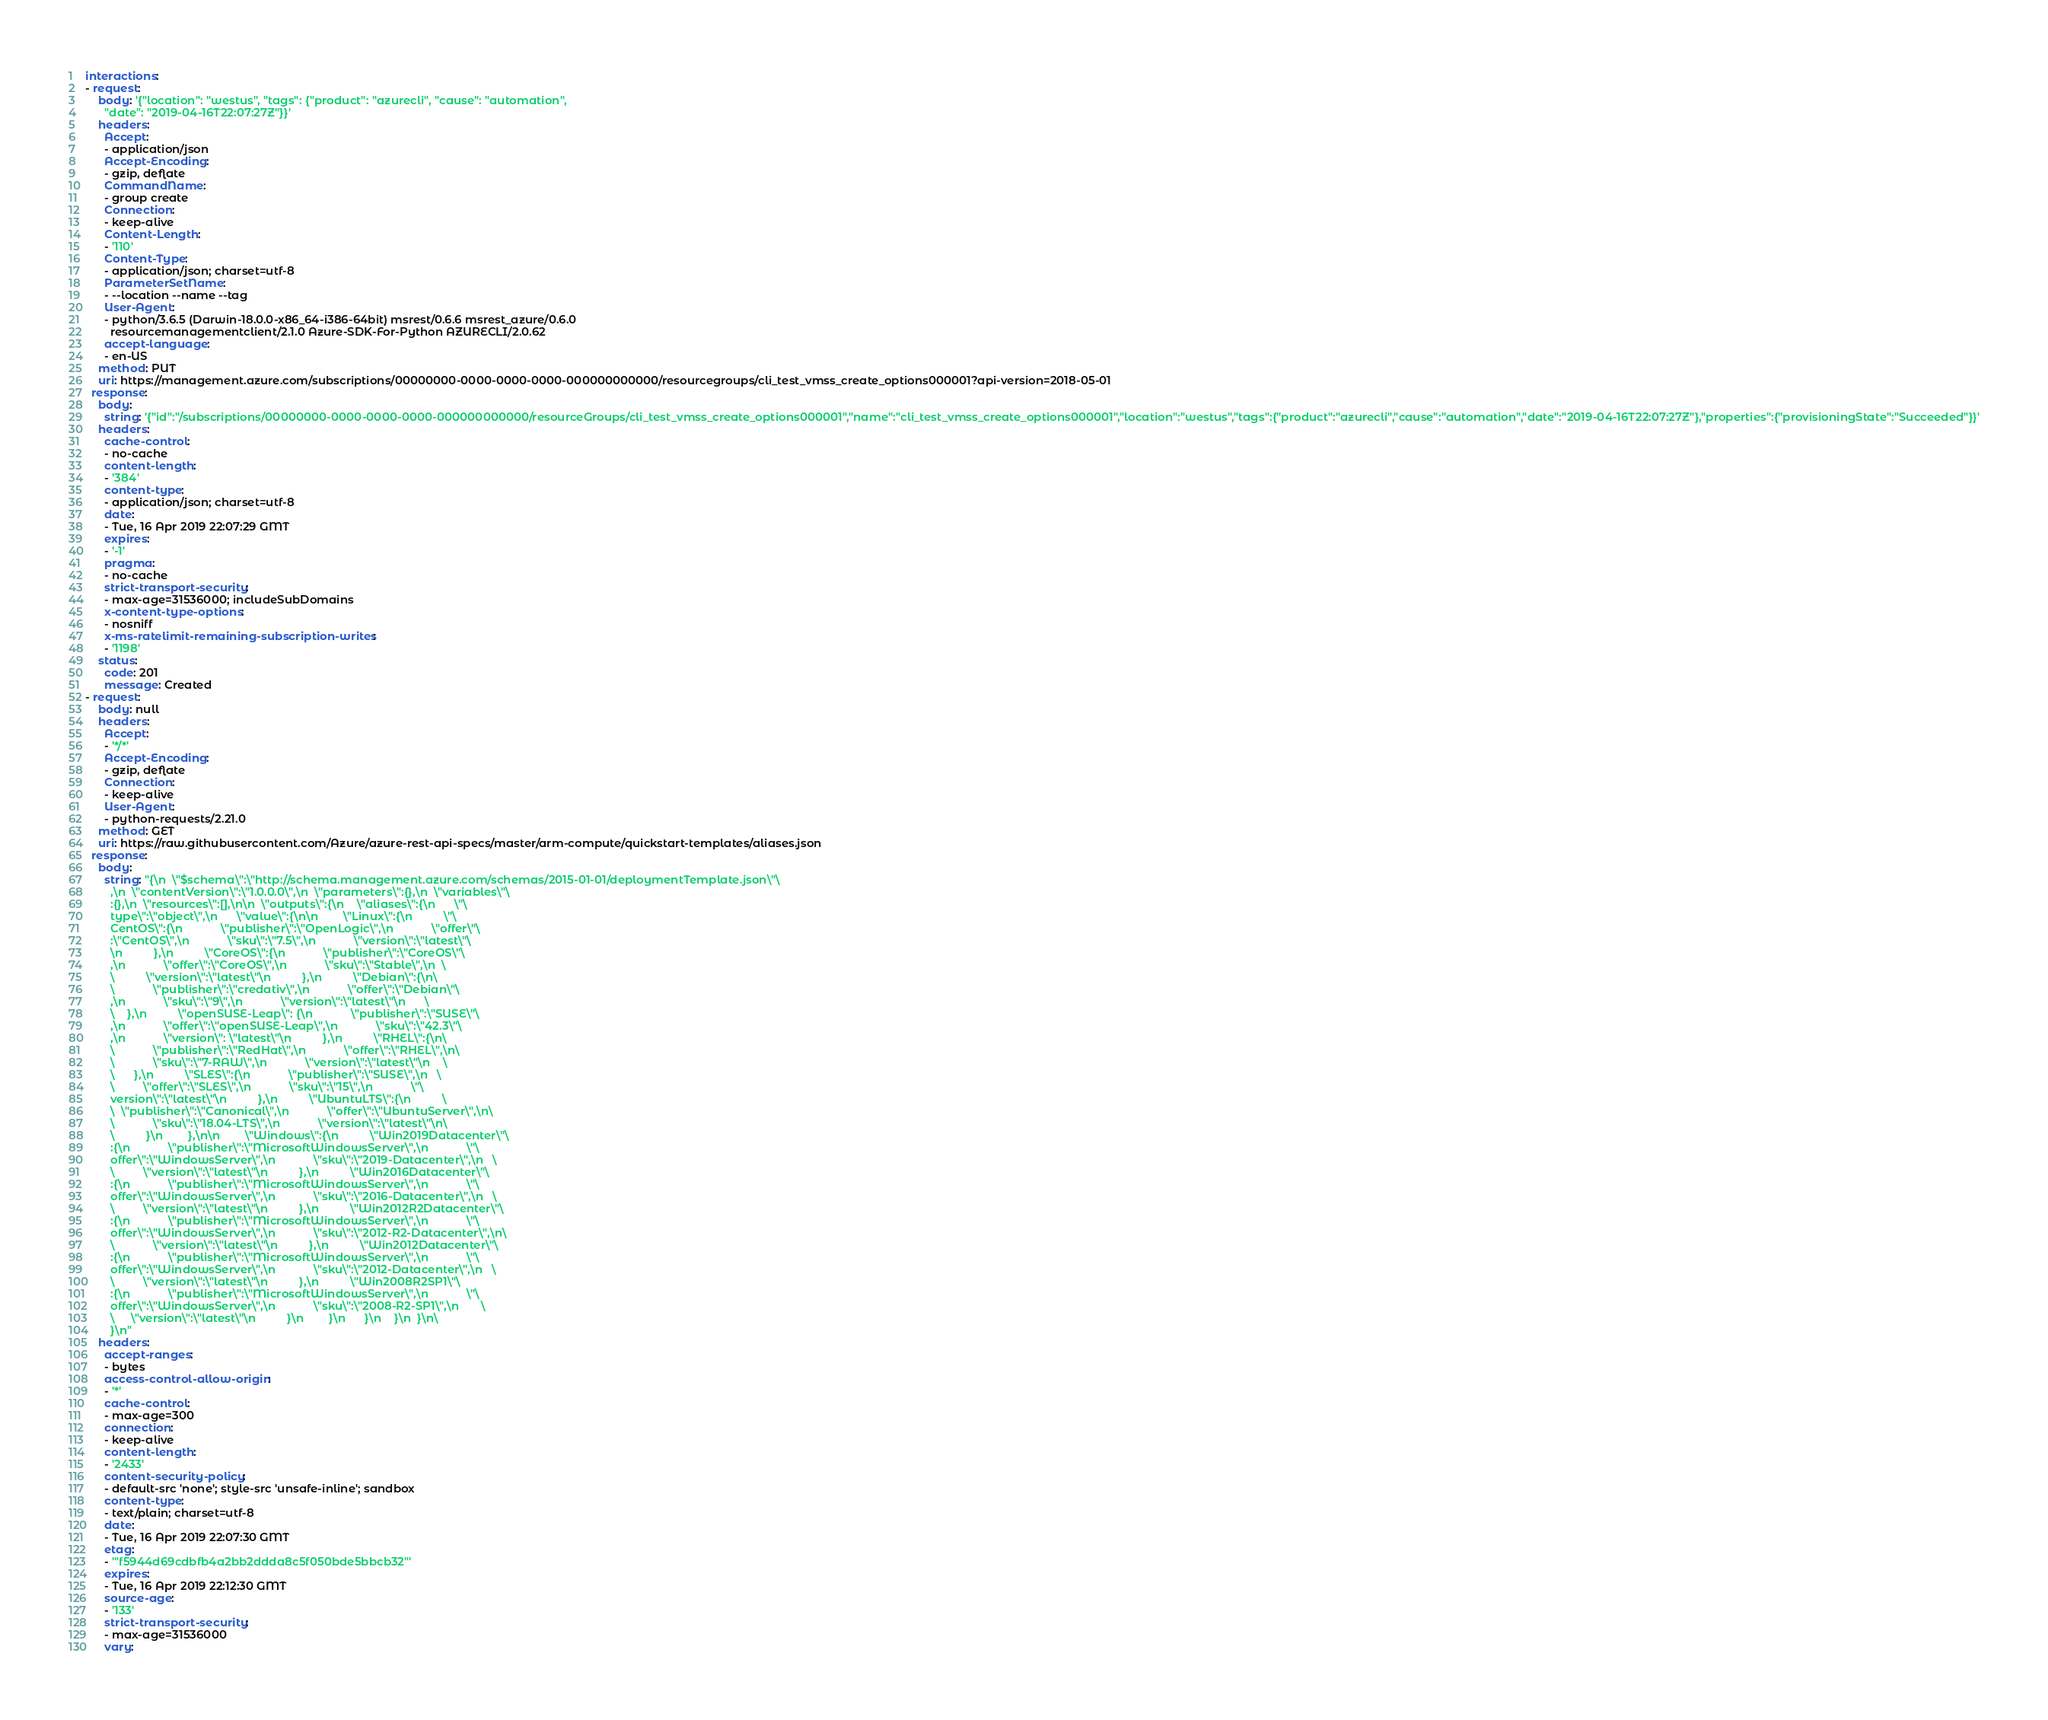<code> <loc_0><loc_0><loc_500><loc_500><_YAML_>interactions:
- request:
    body: '{"location": "westus", "tags": {"product": "azurecli", "cause": "automation",
      "date": "2019-04-16T22:07:27Z"}}'
    headers:
      Accept:
      - application/json
      Accept-Encoding:
      - gzip, deflate
      CommandName:
      - group create
      Connection:
      - keep-alive
      Content-Length:
      - '110'
      Content-Type:
      - application/json; charset=utf-8
      ParameterSetName:
      - --location --name --tag
      User-Agent:
      - python/3.6.5 (Darwin-18.0.0-x86_64-i386-64bit) msrest/0.6.6 msrest_azure/0.6.0
        resourcemanagementclient/2.1.0 Azure-SDK-For-Python AZURECLI/2.0.62
      accept-language:
      - en-US
    method: PUT
    uri: https://management.azure.com/subscriptions/00000000-0000-0000-0000-000000000000/resourcegroups/cli_test_vmss_create_options000001?api-version=2018-05-01
  response:
    body:
      string: '{"id":"/subscriptions/00000000-0000-0000-0000-000000000000/resourceGroups/cli_test_vmss_create_options000001","name":"cli_test_vmss_create_options000001","location":"westus","tags":{"product":"azurecli","cause":"automation","date":"2019-04-16T22:07:27Z"},"properties":{"provisioningState":"Succeeded"}}'
    headers:
      cache-control:
      - no-cache
      content-length:
      - '384'
      content-type:
      - application/json; charset=utf-8
      date:
      - Tue, 16 Apr 2019 22:07:29 GMT
      expires:
      - '-1'
      pragma:
      - no-cache
      strict-transport-security:
      - max-age=31536000; includeSubDomains
      x-content-type-options:
      - nosniff
      x-ms-ratelimit-remaining-subscription-writes:
      - '1198'
    status:
      code: 201
      message: Created
- request:
    body: null
    headers:
      Accept:
      - '*/*'
      Accept-Encoding:
      - gzip, deflate
      Connection:
      - keep-alive
      User-Agent:
      - python-requests/2.21.0
    method: GET
    uri: https://raw.githubusercontent.com/Azure/azure-rest-api-specs/master/arm-compute/quickstart-templates/aliases.json
  response:
    body:
      string: "{\n  \"$schema\":\"http://schema.management.azure.com/schemas/2015-01-01/deploymentTemplate.json\"\
        ,\n  \"contentVersion\":\"1.0.0.0\",\n  \"parameters\":{},\n  \"variables\"\
        :{},\n  \"resources\":[],\n\n  \"outputs\":{\n    \"aliases\":{\n      \"\
        type\":\"object\",\n      \"value\":{\n\n        \"Linux\":{\n          \"\
        CentOS\":{\n            \"publisher\":\"OpenLogic\",\n            \"offer\"\
        :\"CentOS\",\n            \"sku\":\"7.5\",\n            \"version\":\"latest\"\
        \n          },\n          \"CoreOS\":{\n            \"publisher\":\"CoreOS\"\
        ,\n            \"offer\":\"CoreOS\",\n            \"sku\":\"Stable\",\n  \
        \          \"version\":\"latest\"\n          },\n          \"Debian\":{\n\
        \            \"publisher\":\"credativ\",\n            \"offer\":\"Debian\"\
        ,\n            \"sku\":\"9\",\n            \"version\":\"latest\"\n      \
        \    },\n          \"openSUSE-Leap\": {\n            \"publisher\":\"SUSE\"\
        ,\n            \"offer\":\"openSUSE-Leap\",\n            \"sku\":\"42.3\"\
        ,\n            \"version\": \"latest\"\n          },\n          \"RHEL\":{\n\
        \            \"publisher\":\"RedHat\",\n            \"offer\":\"RHEL\",\n\
        \            \"sku\":\"7-RAW\",\n            \"version\":\"latest\"\n    \
        \      },\n          \"SLES\":{\n            \"publisher\":\"SUSE\",\n   \
        \         \"offer\":\"SLES\",\n            \"sku\":\"15\",\n            \"\
        version\":\"latest\"\n          },\n          \"UbuntuLTS\":{\n          \
        \  \"publisher\":\"Canonical\",\n            \"offer\":\"UbuntuServer\",\n\
        \            \"sku\":\"18.04-LTS\",\n            \"version\":\"latest\"\n\
        \          }\n        },\n\n        \"Windows\":{\n          \"Win2019Datacenter\"\
        :{\n            \"publisher\":\"MicrosoftWindowsServer\",\n            \"\
        offer\":\"WindowsServer\",\n            \"sku\":\"2019-Datacenter\",\n   \
        \         \"version\":\"latest\"\n          },\n          \"Win2016Datacenter\"\
        :{\n            \"publisher\":\"MicrosoftWindowsServer\",\n            \"\
        offer\":\"WindowsServer\",\n            \"sku\":\"2016-Datacenter\",\n   \
        \         \"version\":\"latest\"\n          },\n          \"Win2012R2Datacenter\"\
        :{\n            \"publisher\":\"MicrosoftWindowsServer\",\n            \"\
        offer\":\"WindowsServer\",\n            \"sku\":\"2012-R2-Datacenter\",\n\
        \            \"version\":\"latest\"\n          },\n          \"Win2012Datacenter\"\
        :{\n            \"publisher\":\"MicrosoftWindowsServer\",\n            \"\
        offer\":\"WindowsServer\",\n            \"sku\":\"2012-Datacenter\",\n   \
        \         \"version\":\"latest\"\n          },\n          \"Win2008R2SP1\"\
        :{\n            \"publisher\":\"MicrosoftWindowsServer\",\n            \"\
        offer\":\"WindowsServer\",\n            \"sku\":\"2008-R2-SP1\",\n       \
        \     \"version\":\"latest\"\n          }\n        }\n      }\n    }\n  }\n\
        }\n"
    headers:
      accept-ranges:
      - bytes
      access-control-allow-origin:
      - '*'
      cache-control:
      - max-age=300
      connection:
      - keep-alive
      content-length:
      - '2433'
      content-security-policy:
      - default-src 'none'; style-src 'unsafe-inline'; sandbox
      content-type:
      - text/plain; charset=utf-8
      date:
      - Tue, 16 Apr 2019 22:07:30 GMT
      etag:
      - '"f5944d69cdbfb4a2bb2ddda8c5f050bde5bbcb32"'
      expires:
      - Tue, 16 Apr 2019 22:12:30 GMT
      source-age:
      - '133'
      strict-transport-security:
      - max-age=31536000
      vary:</code> 